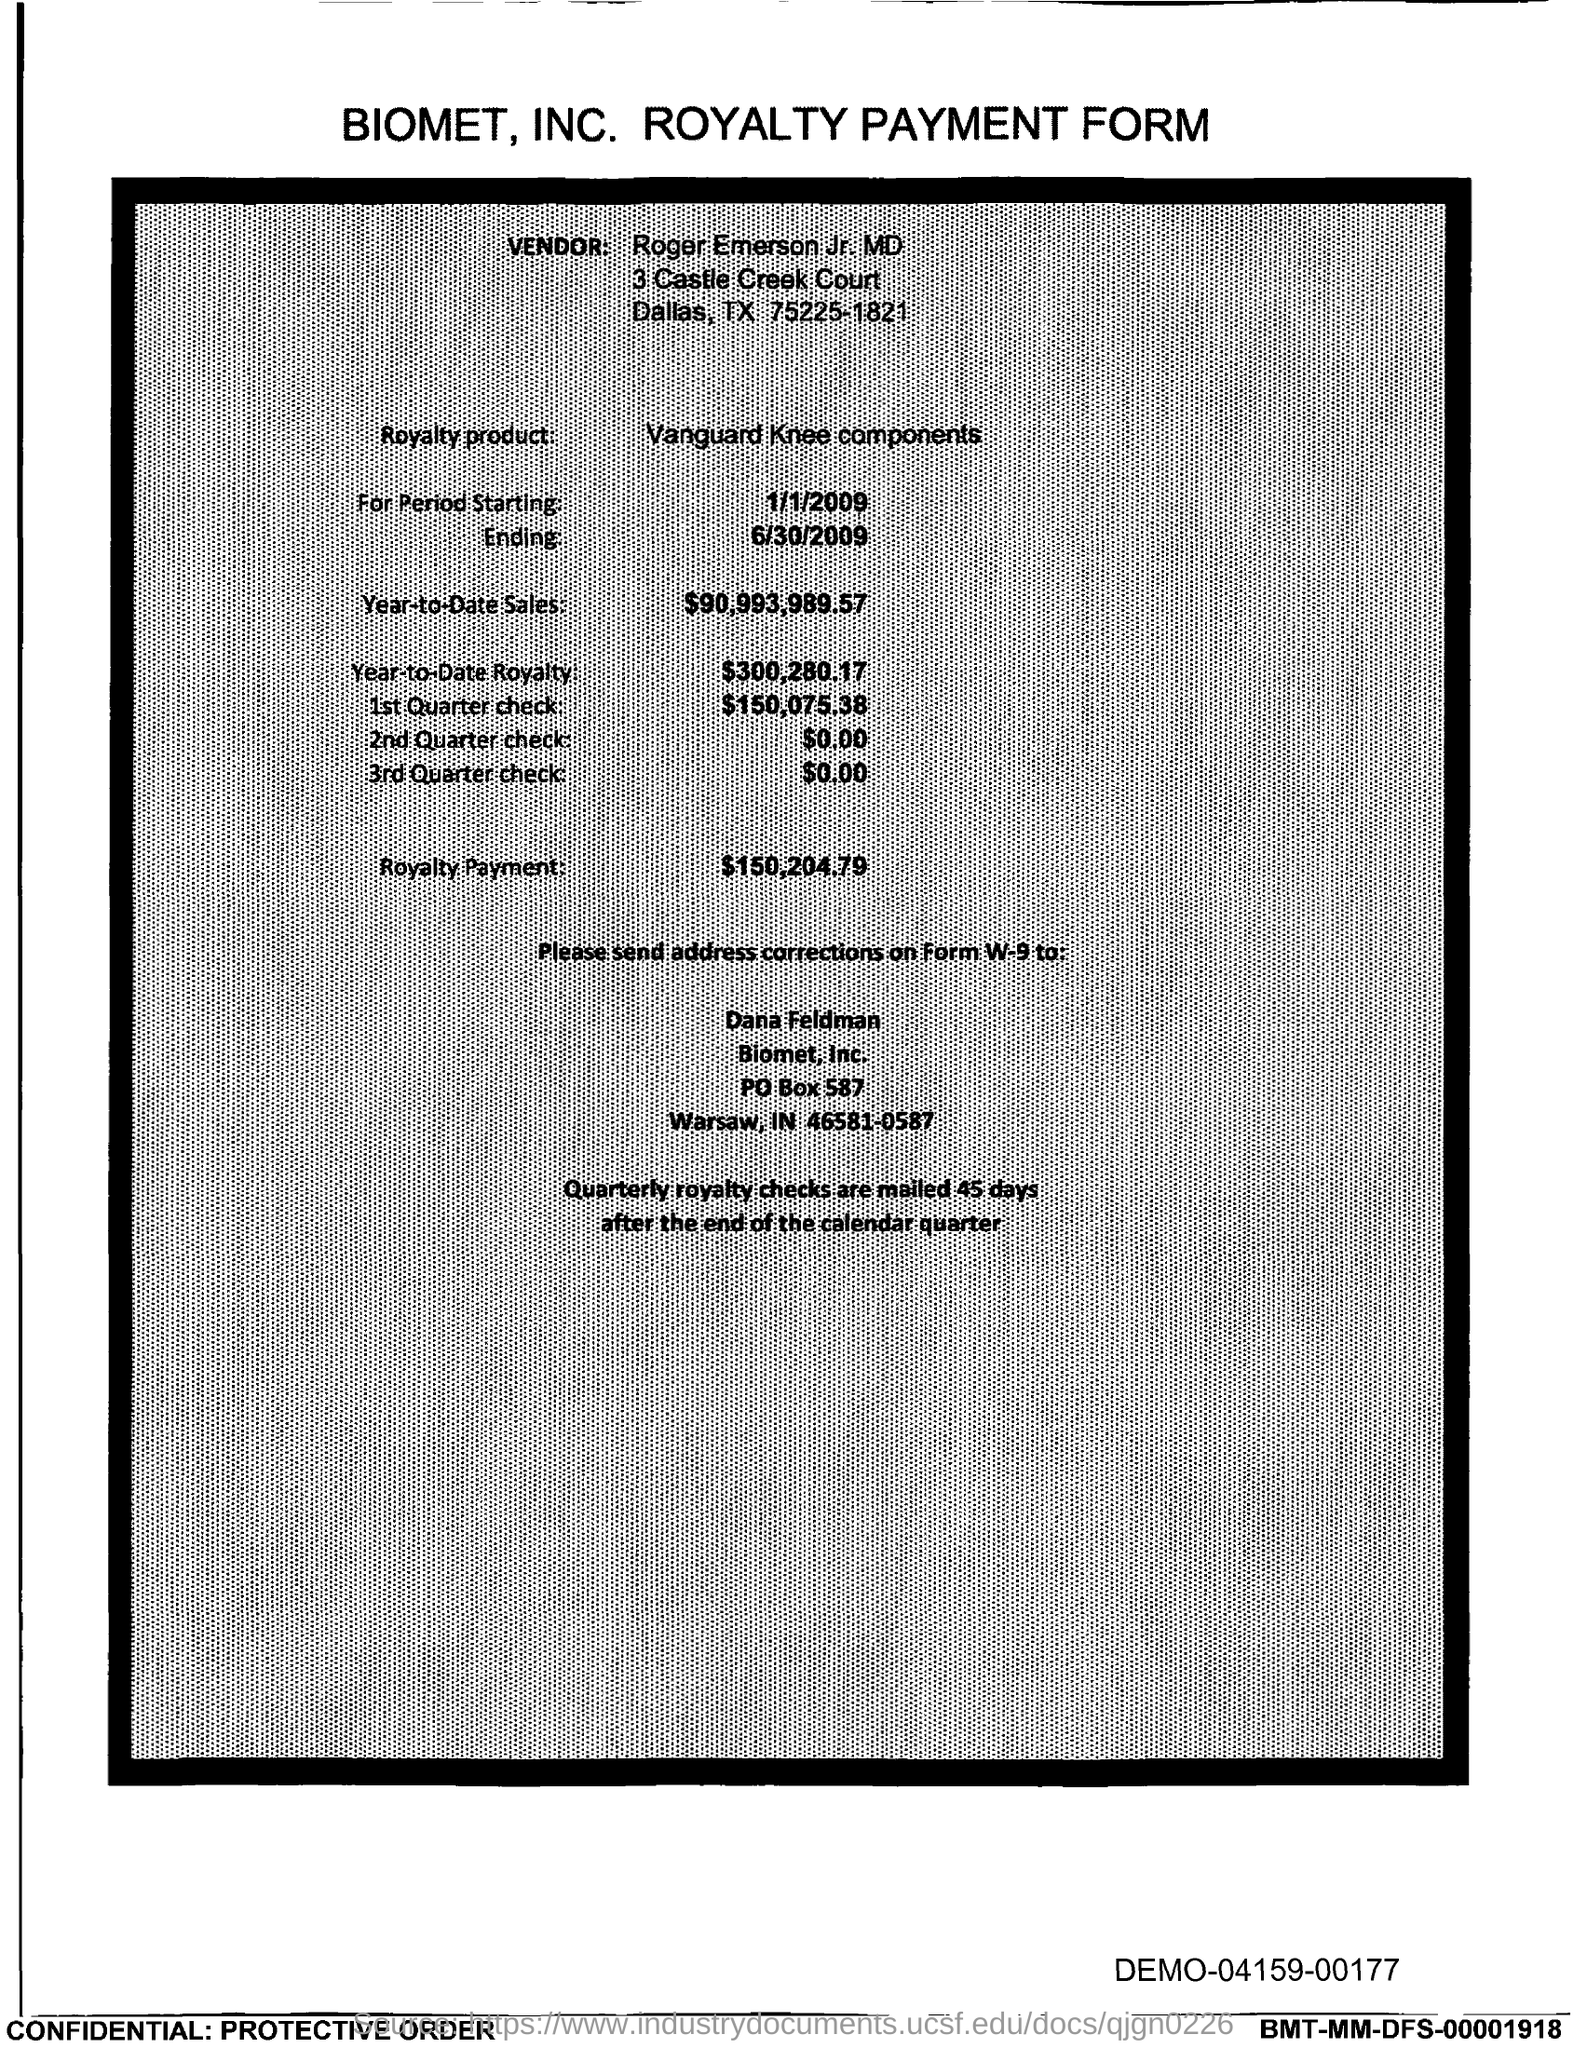Who is the vendor mentioned in the form?
Offer a very short reply. Roger Emerson Jr. MD. What is the royalty product given in the form?
Provide a short and direct response. Vanguard Knee Components. What is the start date of the royalty period?
Your answer should be compact. 1/1/2009. What is the end date of the royalty period?
Provide a short and direct response. 6/30/2009. What is the Year-to-Date Sales of the royalty product?
Make the answer very short. $90,993,989.57. What is the Year-to-Date royalty of the product?
Offer a very short reply. $300,280.17. What is the amount of 1st quarter check mentioned in the form?
Provide a short and direct response. $150,075.38. What is the amount of 2nd Quarter check mentioned in the form?
Provide a succinct answer. $0.00. What is the royalty payment of the product mentioned in the form?
Make the answer very short. $150,204.79. 